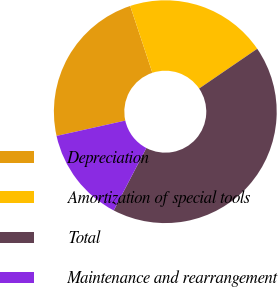Convert chart. <chart><loc_0><loc_0><loc_500><loc_500><pie_chart><fcel>Depreciation<fcel>Amortization of special tools<fcel>Total<fcel>Maintenance and rearrangement<nl><fcel>23.39%<fcel>20.55%<fcel>42.21%<fcel>13.85%<nl></chart> 